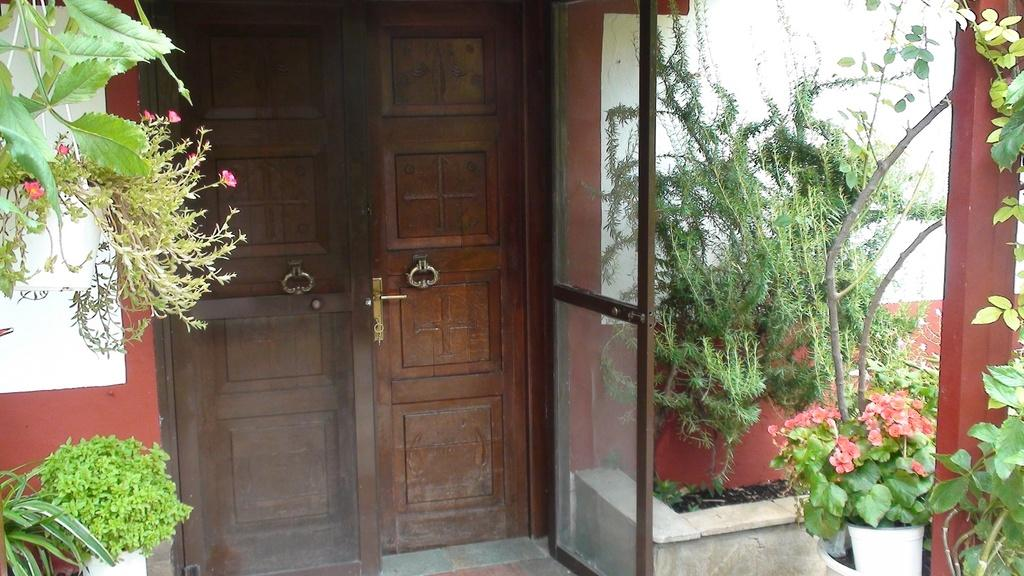What is a prominent feature in the image? There is a door in the image. What type of vegetation can be seen in the image? There are plants and flowers in the image. What is the background of the image made of? There is a wall in the image. What type of crime is being committed in the image? There is no indication of any crime being committed in the image. Is there a tent visible in the image? No, there is no tent present in the image. 